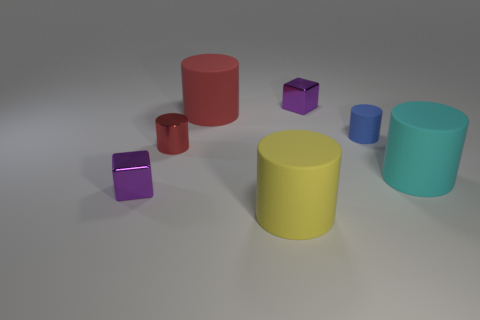What number of other things are the same shape as the blue matte thing?
Provide a succinct answer. 4. How many objects are either matte objects behind the big cyan rubber cylinder or tiny purple metallic things that are to the left of the red shiny object?
Your response must be concise. 3. How many other things are the same color as the tiny rubber cylinder?
Your response must be concise. 0. Is the number of purple objects in front of the large cyan object less than the number of big red objects on the right side of the yellow matte object?
Your answer should be compact. No. What number of tiny brown metal blocks are there?
Ensure brevity in your answer.  0. What material is the blue thing that is the same shape as the large red thing?
Give a very brief answer. Rubber. Are there fewer small metallic cubes in front of the small blue rubber thing than small brown matte balls?
Keep it short and to the point. No. Does the red thing that is to the left of the red matte object have the same shape as the yellow thing?
Your response must be concise. Yes. Is there anything else of the same color as the shiny cylinder?
Your answer should be compact. Yes. The blue cylinder that is the same material as the big cyan cylinder is what size?
Offer a terse response. Small. 